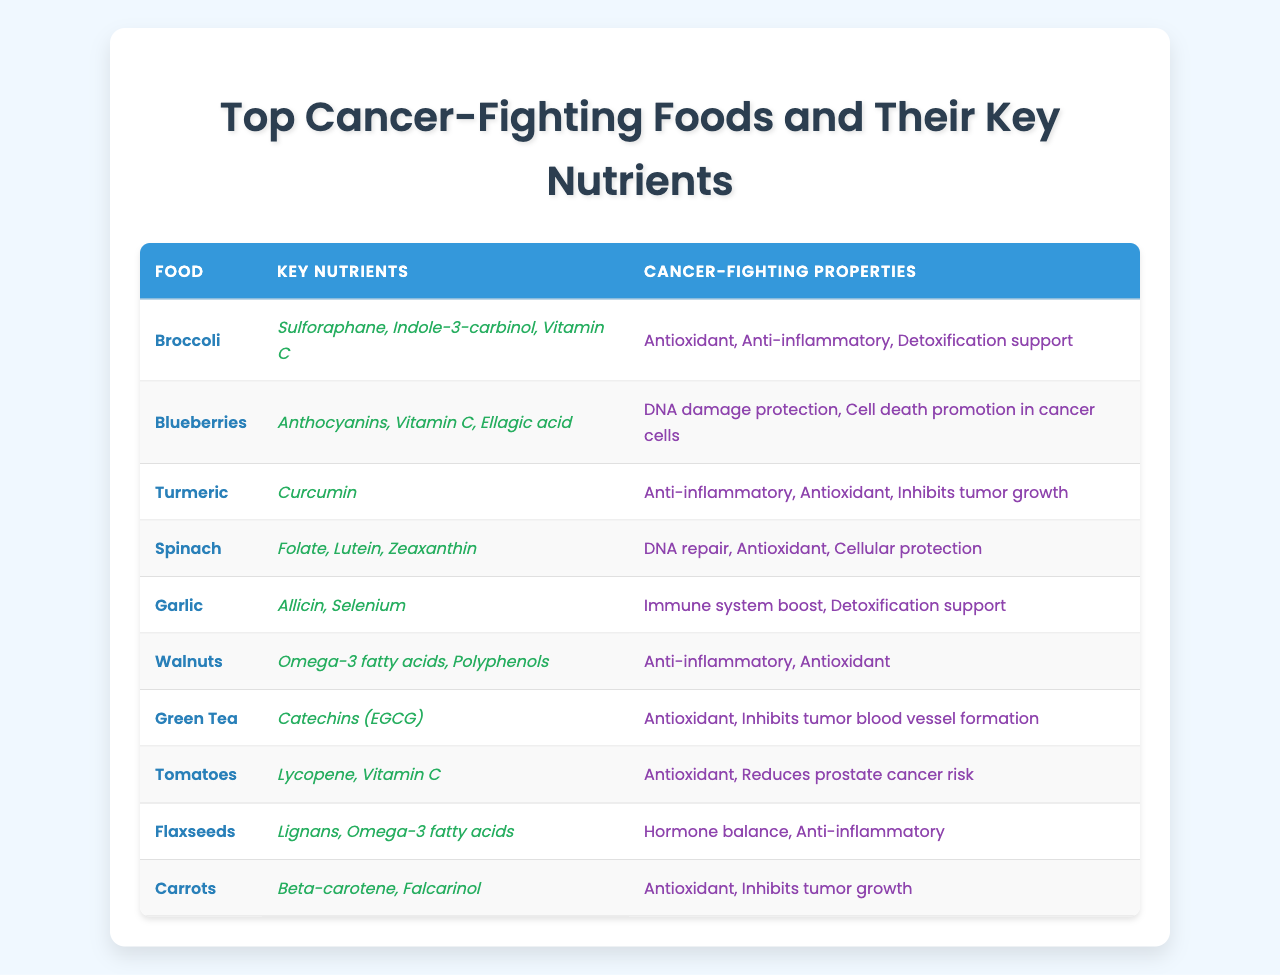What key nutrient is found in tomatoes? The table shows that the key nutrients found in tomatoes are Lycopene and Vitamin C.
Answer: Lycopene, Vitamin C What cancer-fighting property is associated with garlic? According to the table, garlic has cancer-fighting properties including immune system boost and detoxification support.
Answer: Immune system boost, detoxification support Which food has the key nutrient curcumin? The table indicates that turmeric is the food that contains the key nutrient curcumin.
Answer: Turmeric Do all the listed foods have antioxidant properties? Upon examining the table, most of the foods listed, such as broccoli, blueberries, turmeric, spinach, walnuts, green tea, tomatoes, and carrots, have antioxidant properties, confirming that not all confirm this property, but most do.
Answer: Yes, most do Which food has the least number of key nutrients mentioned? By reviewing the table, turmeric is the only food that lists one key nutrient (curcumin), while others mention two or three.
Answer: Turmeric Is lycopene associated with prostate cancer risk reduction? The table states that lycopene in tomatoes is linked to reducing prostate cancer risk, confirming the statement is true.
Answer: Yes What are the two types of fatty acids found in walnuts? From the table, walnuts contain Omega-3 fatty acids and Polyphenols as their key nutrients.
Answer: Omega-3 fatty acids, Polyphenols How many foods are listed that promote DNA protection or repair? Upon reviewing the table, both blueberries and spinach promote DNA protection and repair, indicating there are two foods with this property.
Answer: Two foods Which food has both detoxification support and immune system boost properties? According to the table, garlic is the food that has both detoxification support and immune system boost properties.
Answer: Garlic What is the common cancer-fighting property among broccoli, spinach, and walnuts? The table shows that broccoli, spinach, and walnuts all have antioxidant properties listed, indicating this is a common cancer-fighting property among them.
Answer: Antioxidant properties 